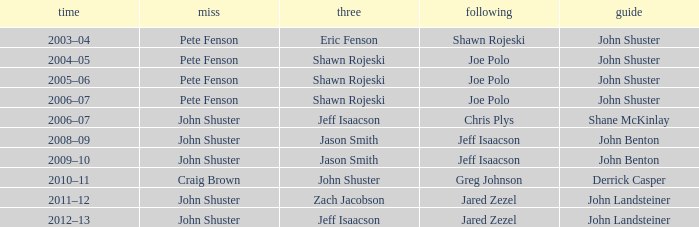Who was the lead with Pete Fenson as skip and Joe Polo as second in season 2005–06? John Shuster. 